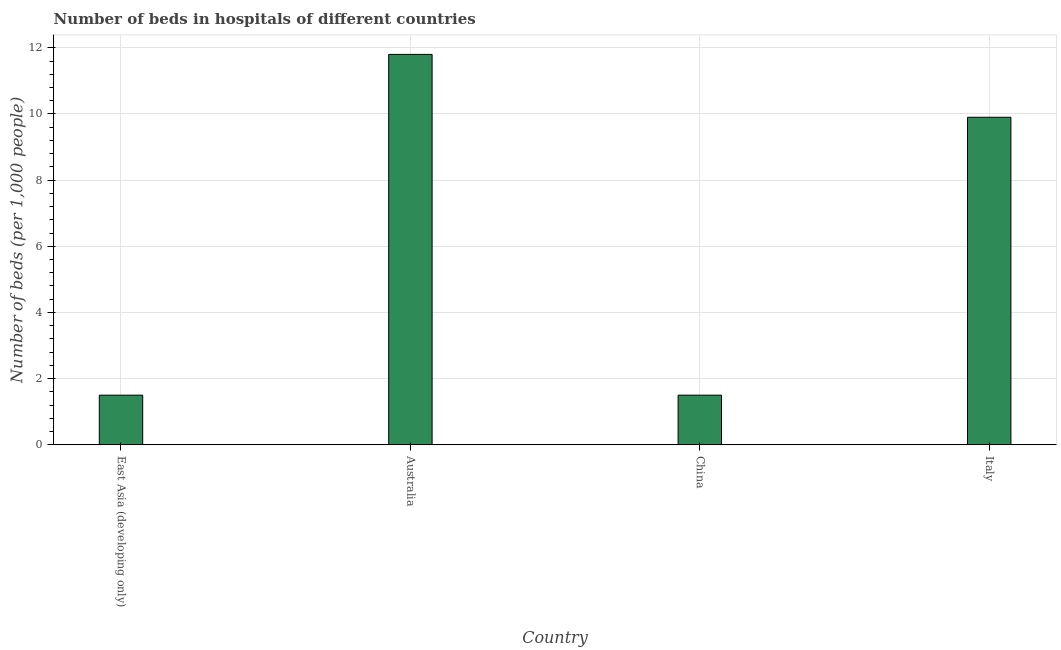Does the graph contain any zero values?
Your response must be concise. No. What is the title of the graph?
Give a very brief answer. Number of beds in hospitals of different countries. What is the label or title of the Y-axis?
Offer a very short reply. Number of beds (per 1,0 people). What is the number of hospital beds in East Asia (developing only)?
Your answer should be very brief. 1.5. Across all countries, what is the maximum number of hospital beds?
Your answer should be compact. 11.8. In which country was the number of hospital beds maximum?
Offer a very short reply. Australia. In which country was the number of hospital beds minimum?
Make the answer very short. East Asia (developing only). What is the sum of the number of hospital beds?
Offer a terse response. 24.7. What is the difference between the number of hospital beds in Australia and China?
Make the answer very short. 10.3. What is the average number of hospital beds per country?
Keep it short and to the point. 6.17. What is the median number of hospital beds?
Your answer should be very brief. 5.7. What is the ratio of the number of hospital beds in Australia to that in East Asia (developing only)?
Keep it short and to the point. 7.87. Is the number of hospital beds in Australia less than that in Italy?
Provide a succinct answer. No. What is the difference between the highest and the second highest number of hospital beds?
Provide a short and direct response. 1.9. What is the difference between the highest and the lowest number of hospital beds?
Provide a short and direct response. 10.3. In how many countries, is the number of hospital beds greater than the average number of hospital beds taken over all countries?
Your answer should be compact. 2. How many bars are there?
Your answer should be compact. 4. Are all the bars in the graph horizontal?
Give a very brief answer. No. How many countries are there in the graph?
Provide a succinct answer. 4. Are the values on the major ticks of Y-axis written in scientific E-notation?
Give a very brief answer. No. What is the Number of beds (per 1,000 people) of Australia?
Keep it short and to the point. 11.8. What is the Number of beds (per 1,000 people) in Italy?
Offer a terse response. 9.9. What is the difference between the Number of beds (per 1,000 people) in East Asia (developing only) and Australia?
Provide a short and direct response. -10.3. What is the difference between the Number of beds (per 1,000 people) in East Asia (developing only) and China?
Your response must be concise. 0. What is the difference between the Number of beds (per 1,000 people) in East Asia (developing only) and Italy?
Provide a succinct answer. -8.4. What is the difference between the Number of beds (per 1,000 people) in Australia and China?
Your response must be concise. 10.3. What is the difference between the Number of beds (per 1,000 people) in China and Italy?
Provide a succinct answer. -8.4. What is the ratio of the Number of beds (per 1,000 people) in East Asia (developing only) to that in Australia?
Provide a short and direct response. 0.13. What is the ratio of the Number of beds (per 1,000 people) in East Asia (developing only) to that in Italy?
Make the answer very short. 0.15. What is the ratio of the Number of beds (per 1,000 people) in Australia to that in China?
Provide a short and direct response. 7.87. What is the ratio of the Number of beds (per 1,000 people) in Australia to that in Italy?
Provide a short and direct response. 1.19. What is the ratio of the Number of beds (per 1,000 people) in China to that in Italy?
Offer a terse response. 0.15. 